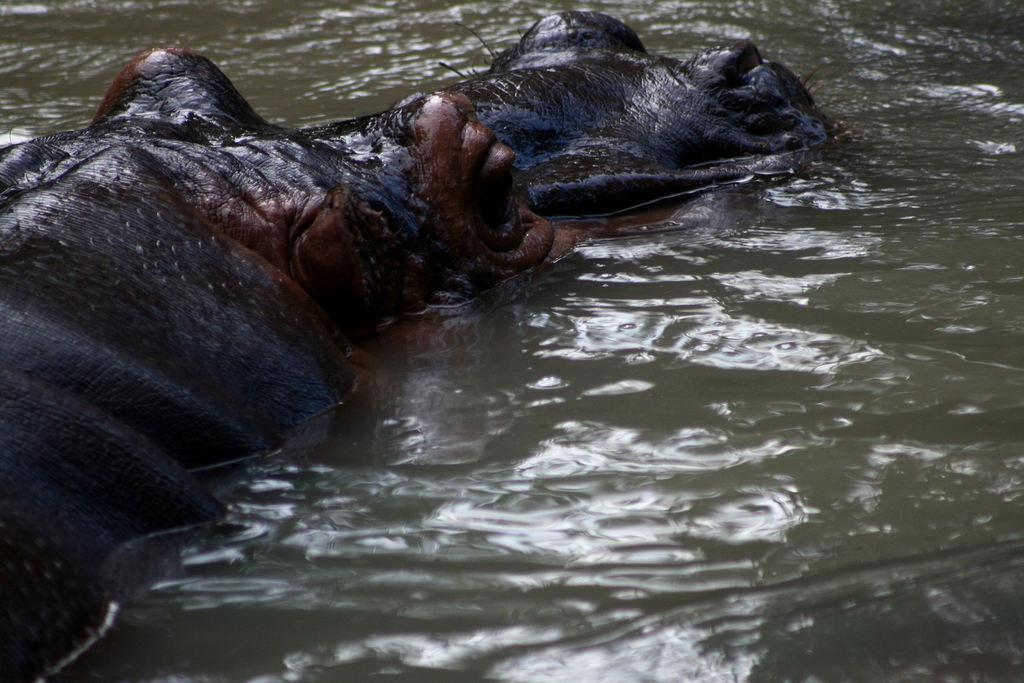What animal is in the image? There is a hippopotamus in the image. Where is the hippopotamus located? The hippopotamus is in the water. What type of bat is the hippopotamus holding in the image? There is no bat present in the image; the hippopotamus is in the water. 